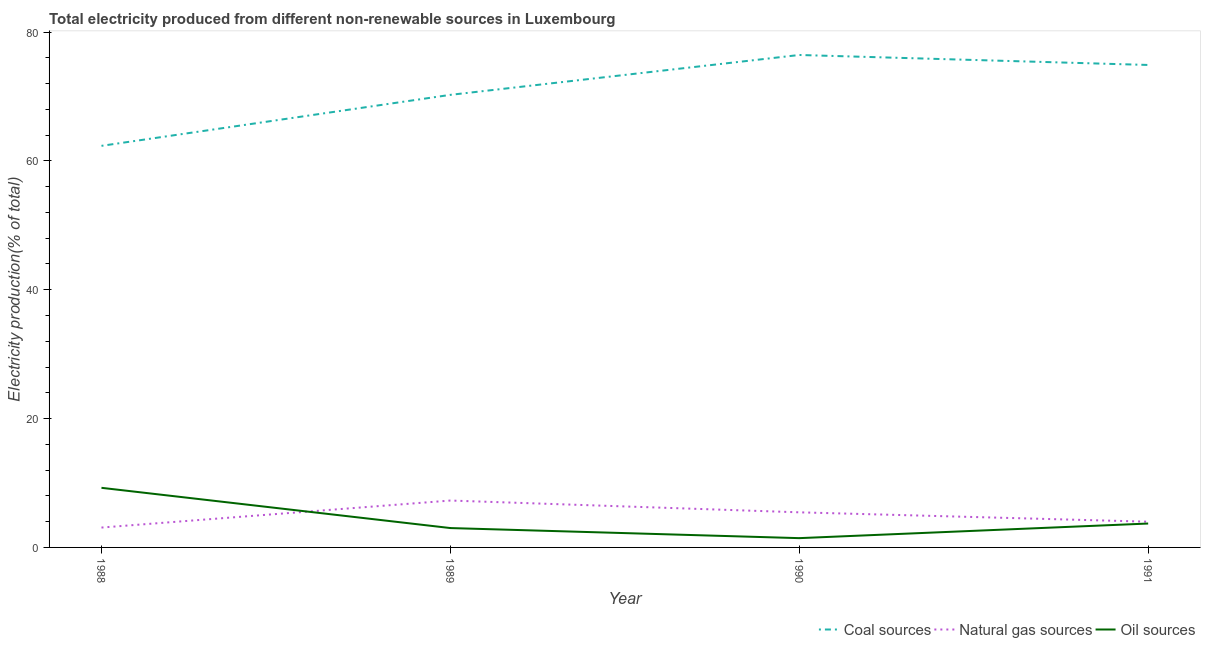How many different coloured lines are there?
Provide a short and direct response. 3. What is the percentage of electricity produced by coal in 1990?
Your response must be concise. 76.44. Across all years, what is the maximum percentage of electricity produced by natural gas?
Your response must be concise. 7.28. Across all years, what is the minimum percentage of electricity produced by natural gas?
Provide a succinct answer. 3.08. In which year was the percentage of electricity produced by natural gas maximum?
Your response must be concise. 1989. In which year was the percentage of electricity produced by coal minimum?
Offer a very short reply. 1988. What is the total percentage of electricity produced by natural gas in the graph?
Offer a very short reply. 19.81. What is the difference between the percentage of electricity produced by natural gas in 1990 and that in 1991?
Provide a short and direct response. 1.45. What is the difference between the percentage of electricity produced by coal in 1988 and the percentage of electricity produced by natural gas in 1989?
Your answer should be compact. 55.06. What is the average percentage of electricity produced by coal per year?
Offer a terse response. 70.98. In the year 1989, what is the difference between the percentage of electricity produced by natural gas and percentage of electricity produced by coal?
Provide a succinct answer. -62.97. In how many years, is the percentage of electricity produced by oil sources greater than 8 %?
Your response must be concise. 1. What is the ratio of the percentage of electricity produced by natural gas in 1988 to that in 1991?
Your answer should be compact. 0.77. Is the difference between the percentage of electricity produced by coal in 1988 and 1991 greater than the difference between the percentage of electricity produced by oil sources in 1988 and 1991?
Ensure brevity in your answer.  No. What is the difference between the highest and the second highest percentage of electricity produced by oil sources?
Your answer should be very brief. 5.54. What is the difference between the highest and the lowest percentage of electricity produced by natural gas?
Ensure brevity in your answer.  4.19. Is the sum of the percentage of electricity produced by coal in 1989 and 1991 greater than the maximum percentage of electricity produced by natural gas across all years?
Make the answer very short. Yes. Is it the case that in every year, the sum of the percentage of electricity produced by coal and percentage of electricity produced by natural gas is greater than the percentage of electricity produced by oil sources?
Offer a terse response. Yes. Does the percentage of electricity produced by coal monotonically increase over the years?
Provide a succinct answer. No. Is the percentage of electricity produced by coal strictly greater than the percentage of electricity produced by natural gas over the years?
Keep it short and to the point. Yes. Is the percentage of electricity produced by coal strictly less than the percentage of electricity produced by natural gas over the years?
Provide a short and direct response. No. How many lines are there?
Offer a terse response. 3. How many years are there in the graph?
Your answer should be compact. 4. What is the difference between two consecutive major ticks on the Y-axis?
Offer a very short reply. 20. Are the values on the major ticks of Y-axis written in scientific E-notation?
Make the answer very short. No. Does the graph contain any zero values?
Make the answer very short. No. Does the graph contain grids?
Offer a terse response. No. What is the title of the graph?
Ensure brevity in your answer.  Total electricity produced from different non-renewable sources in Luxembourg. Does "Labor Tax" appear as one of the legend labels in the graph?
Offer a terse response. No. What is the label or title of the X-axis?
Ensure brevity in your answer.  Year. What is the Electricity production(% of total) in Coal sources in 1988?
Ensure brevity in your answer.  62.34. What is the Electricity production(% of total) of Natural gas sources in 1988?
Give a very brief answer. 3.08. What is the Electricity production(% of total) in Oil sources in 1988?
Provide a short and direct response. 9.25. What is the Electricity production(% of total) in Coal sources in 1989?
Provide a short and direct response. 70.25. What is the Electricity production(% of total) of Natural gas sources in 1989?
Offer a very short reply. 7.28. What is the Electricity production(% of total) in Oil sources in 1989?
Provide a succinct answer. 3.01. What is the Electricity production(% of total) of Coal sources in 1990?
Make the answer very short. 76.44. What is the Electricity production(% of total) of Natural gas sources in 1990?
Keep it short and to the point. 5.45. What is the Electricity production(% of total) of Oil sources in 1990?
Ensure brevity in your answer.  1.44. What is the Electricity production(% of total) in Coal sources in 1991?
Make the answer very short. 74.89. What is the Electricity production(% of total) of Natural gas sources in 1991?
Your answer should be very brief. 3.99. What is the Electricity production(% of total) in Oil sources in 1991?
Your answer should be compact. 3.71. Across all years, what is the maximum Electricity production(% of total) in Coal sources?
Offer a very short reply. 76.44. Across all years, what is the maximum Electricity production(% of total) of Natural gas sources?
Your response must be concise. 7.28. Across all years, what is the maximum Electricity production(% of total) of Oil sources?
Offer a very short reply. 9.25. Across all years, what is the minimum Electricity production(% of total) in Coal sources?
Give a very brief answer. 62.34. Across all years, what is the minimum Electricity production(% of total) of Natural gas sources?
Offer a very short reply. 3.08. Across all years, what is the minimum Electricity production(% of total) of Oil sources?
Ensure brevity in your answer.  1.44. What is the total Electricity production(% of total) in Coal sources in the graph?
Your answer should be compact. 283.93. What is the total Electricity production(% of total) in Natural gas sources in the graph?
Provide a succinct answer. 19.81. What is the total Electricity production(% of total) of Oil sources in the graph?
Give a very brief answer. 17.41. What is the difference between the Electricity production(% of total) in Coal sources in 1988 and that in 1989?
Make the answer very short. -7.92. What is the difference between the Electricity production(% of total) in Natural gas sources in 1988 and that in 1989?
Your response must be concise. -4.19. What is the difference between the Electricity production(% of total) of Oil sources in 1988 and that in 1989?
Give a very brief answer. 6.25. What is the difference between the Electricity production(% of total) in Coal sources in 1988 and that in 1990?
Provide a short and direct response. -14.1. What is the difference between the Electricity production(% of total) in Natural gas sources in 1988 and that in 1990?
Provide a short and direct response. -2.36. What is the difference between the Electricity production(% of total) in Oil sources in 1988 and that in 1990?
Provide a succinct answer. 7.81. What is the difference between the Electricity production(% of total) of Coal sources in 1988 and that in 1991?
Provide a succinct answer. -12.56. What is the difference between the Electricity production(% of total) in Natural gas sources in 1988 and that in 1991?
Offer a very short reply. -0.91. What is the difference between the Electricity production(% of total) of Oil sources in 1988 and that in 1991?
Keep it short and to the point. 5.54. What is the difference between the Electricity production(% of total) in Coal sources in 1989 and that in 1990?
Provide a short and direct response. -6.19. What is the difference between the Electricity production(% of total) in Natural gas sources in 1989 and that in 1990?
Provide a succinct answer. 1.83. What is the difference between the Electricity production(% of total) in Oil sources in 1989 and that in 1990?
Offer a very short reply. 1.56. What is the difference between the Electricity production(% of total) in Coal sources in 1989 and that in 1991?
Give a very brief answer. -4.64. What is the difference between the Electricity production(% of total) of Natural gas sources in 1989 and that in 1991?
Make the answer very short. 3.28. What is the difference between the Electricity production(% of total) of Oil sources in 1989 and that in 1991?
Ensure brevity in your answer.  -0.7. What is the difference between the Electricity production(% of total) of Coal sources in 1990 and that in 1991?
Provide a short and direct response. 1.55. What is the difference between the Electricity production(% of total) of Natural gas sources in 1990 and that in 1991?
Give a very brief answer. 1.45. What is the difference between the Electricity production(% of total) of Oil sources in 1990 and that in 1991?
Make the answer very short. -2.27. What is the difference between the Electricity production(% of total) of Coal sources in 1988 and the Electricity production(% of total) of Natural gas sources in 1989?
Provide a short and direct response. 55.06. What is the difference between the Electricity production(% of total) of Coal sources in 1988 and the Electricity production(% of total) of Oil sources in 1989?
Your answer should be compact. 59.33. What is the difference between the Electricity production(% of total) of Natural gas sources in 1988 and the Electricity production(% of total) of Oil sources in 1989?
Offer a terse response. 0.08. What is the difference between the Electricity production(% of total) of Coal sources in 1988 and the Electricity production(% of total) of Natural gas sources in 1990?
Your response must be concise. 56.89. What is the difference between the Electricity production(% of total) in Coal sources in 1988 and the Electricity production(% of total) in Oil sources in 1990?
Give a very brief answer. 60.9. What is the difference between the Electricity production(% of total) in Natural gas sources in 1988 and the Electricity production(% of total) in Oil sources in 1990?
Your answer should be compact. 1.64. What is the difference between the Electricity production(% of total) of Coal sources in 1988 and the Electricity production(% of total) of Natural gas sources in 1991?
Ensure brevity in your answer.  58.34. What is the difference between the Electricity production(% of total) in Coal sources in 1988 and the Electricity production(% of total) in Oil sources in 1991?
Your answer should be compact. 58.63. What is the difference between the Electricity production(% of total) of Natural gas sources in 1988 and the Electricity production(% of total) of Oil sources in 1991?
Provide a succinct answer. -0.62. What is the difference between the Electricity production(% of total) of Coal sources in 1989 and the Electricity production(% of total) of Natural gas sources in 1990?
Offer a very short reply. 64.8. What is the difference between the Electricity production(% of total) in Coal sources in 1989 and the Electricity production(% of total) in Oil sources in 1990?
Provide a short and direct response. 68.81. What is the difference between the Electricity production(% of total) in Natural gas sources in 1989 and the Electricity production(% of total) in Oil sources in 1990?
Offer a terse response. 5.84. What is the difference between the Electricity production(% of total) in Coal sources in 1989 and the Electricity production(% of total) in Natural gas sources in 1991?
Your answer should be compact. 66.26. What is the difference between the Electricity production(% of total) in Coal sources in 1989 and the Electricity production(% of total) in Oil sources in 1991?
Your response must be concise. 66.54. What is the difference between the Electricity production(% of total) in Natural gas sources in 1989 and the Electricity production(% of total) in Oil sources in 1991?
Provide a short and direct response. 3.57. What is the difference between the Electricity production(% of total) in Coal sources in 1990 and the Electricity production(% of total) in Natural gas sources in 1991?
Make the answer very short. 72.45. What is the difference between the Electricity production(% of total) in Coal sources in 1990 and the Electricity production(% of total) in Oil sources in 1991?
Offer a terse response. 72.73. What is the difference between the Electricity production(% of total) of Natural gas sources in 1990 and the Electricity production(% of total) of Oil sources in 1991?
Your response must be concise. 1.74. What is the average Electricity production(% of total) of Coal sources per year?
Your answer should be compact. 70.98. What is the average Electricity production(% of total) of Natural gas sources per year?
Your response must be concise. 4.95. What is the average Electricity production(% of total) in Oil sources per year?
Give a very brief answer. 4.35. In the year 1988, what is the difference between the Electricity production(% of total) of Coal sources and Electricity production(% of total) of Natural gas sources?
Keep it short and to the point. 59.25. In the year 1988, what is the difference between the Electricity production(% of total) of Coal sources and Electricity production(% of total) of Oil sources?
Keep it short and to the point. 53.08. In the year 1988, what is the difference between the Electricity production(% of total) of Natural gas sources and Electricity production(% of total) of Oil sources?
Your answer should be very brief. -6.17. In the year 1989, what is the difference between the Electricity production(% of total) of Coal sources and Electricity production(% of total) of Natural gas sources?
Offer a very short reply. 62.97. In the year 1989, what is the difference between the Electricity production(% of total) in Coal sources and Electricity production(% of total) in Oil sources?
Your answer should be compact. 67.25. In the year 1989, what is the difference between the Electricity production(% of total) of Natural gas sources and Electricity production(% of total) of Oil sources?
Your answer should be compact. 4.27. In the year 1990, what is the difference between the Electricity production(% of total) in Coal sources and Electricity production(% of total) in Natural gas sources?
Keep it short and to the point. 70.99. In the year 1990, what is the difference between the Electricity production(% of total) in Coal sources and Electricity production(% of total) in Oil sources?
Provide a succinct answer. 75. In the year 1990, what is the difference between the Electricity production(% of total) of Natural gas sources and Electricity production(% of total) of Oil sources?
Provide a succinct answer. 4.01. In the year 1991, what is the difference between the Electricity production(% of total) of Coal sources and Electricity production(% of total) of Natural gas sources?
Provide a succinct answer. 70.9. In the year 1991, what is the difference between the Electricity production(% of total) of Coal sources and Electricity production(% of total) of Oil sources?
Your answer should be compact. 71.18. In the year 1991, what is the difference between the Electricity production(% of total) in Natural gas sources and Electricity production(% of total) in Oil sources?
Offer a very short reply. 0.29. What is the ratio of the Electricity production(% of total) in Coal sources in 1988 to that in 1989?
Give a very brief answer. 0.89. What is the ratio of the Electricity production(% of total) of Natural gas sources in 1988 to that in 1989?
Make the answer very short. 0.42. What is the ratio of the Electricity production(% of total) of Oil sources in 1988 to that in 1989?
Give a very brief answer. 3.08. What is the ratio of the Electricity production(% of total) in Coal sources in 1988 to that in 1990?
Offer a very short reply. 0.82. What is the ratio of the Electricity production(% of total) in Natural gas sources in 1988 to that in 1990?
Give a very brief answer. 0.57. What is the ratio of the Electricity production(% of total) in Oil sources in 1988 to that in 1990?
Provide a short and direct response. 6.42. What is the ratio of the Electricity production(% of total) of Coal sources in 1988 to that in 1991?
Provide a succinct answer. 0.83. What is the ratio of the Electricity production(% of total) of Natural gas sources in 1988 to that in 1991?
Make the answer very short. 0.77. What is the ratio of the Electricity production(% of total) in Oil sources in 1988 to that in 1991?
Keep it short and to the point. 2.49. What is the ratio of the Electricity production(% of total) in Coal sources in 1989 to that in 1990?
Give a very brief answer. 0.92. What is the ratio of the Electricity production(% of total) of Natural gas sources in 1989 to that in 1990?
Give a very brief answer. 1.34. What is the ratio of the Electricity production(% of total) in Oil sources in 1989 to that in 1990?
Your response must be concise. 2.08. What is the ratio of the Electricity production(% of total) in Coal sources in 1989 to that in 1991?
Offer a very short reply. 0.94. What is the ratio of the Electricity production(% of total) in Natural gas sources in 1989 to that in 1991?
Your answer should be compact. 1.82. What is the ratio of the Electricity production(% of total) of Oil sources in 1989 to that in 1991?
Your answer should be very brief. 0.81. What is the ratio of the Electricity production(% of total) of Coal sources in 1990 to that in 1991?
Your answer should be compact. 1.02. What is the ratio of the Electricity production(% of total) in Natural gas sources in 1990 to that in 1991?
Your answer should be compact. 1.36. What is the ratio of the Electricity production(% of total) in Oil sources in 1990 to that in 1991?
Give a very brief answer. 0.39. What is the difference between the highest and the second highest Electricity production(% of total) in Coal sources?
Provide a short and direct response. 1.55. What is the difference between the highest and the second highest Electricity production(% of total) in Natural gas sources?
Your answer should be very brief. 1.83. What is the difference between the highest and the second highest Electricity production(% of total) of Oil sources?
Give a very brief answer. 5.54. What is the difference between the highest and the lowest Electricity production(% of total) of Coal sources?
Make the answer very short. 14.1. What is the difference between the highest and the lowest Electricity production(% of total) in Natural gas sources?
Ensure brevity in your answer.  4.19. What is the difference between the highest and the lowest Electricity production(% of total) of Oil sources?
Give a very brief answer. 7.81. 